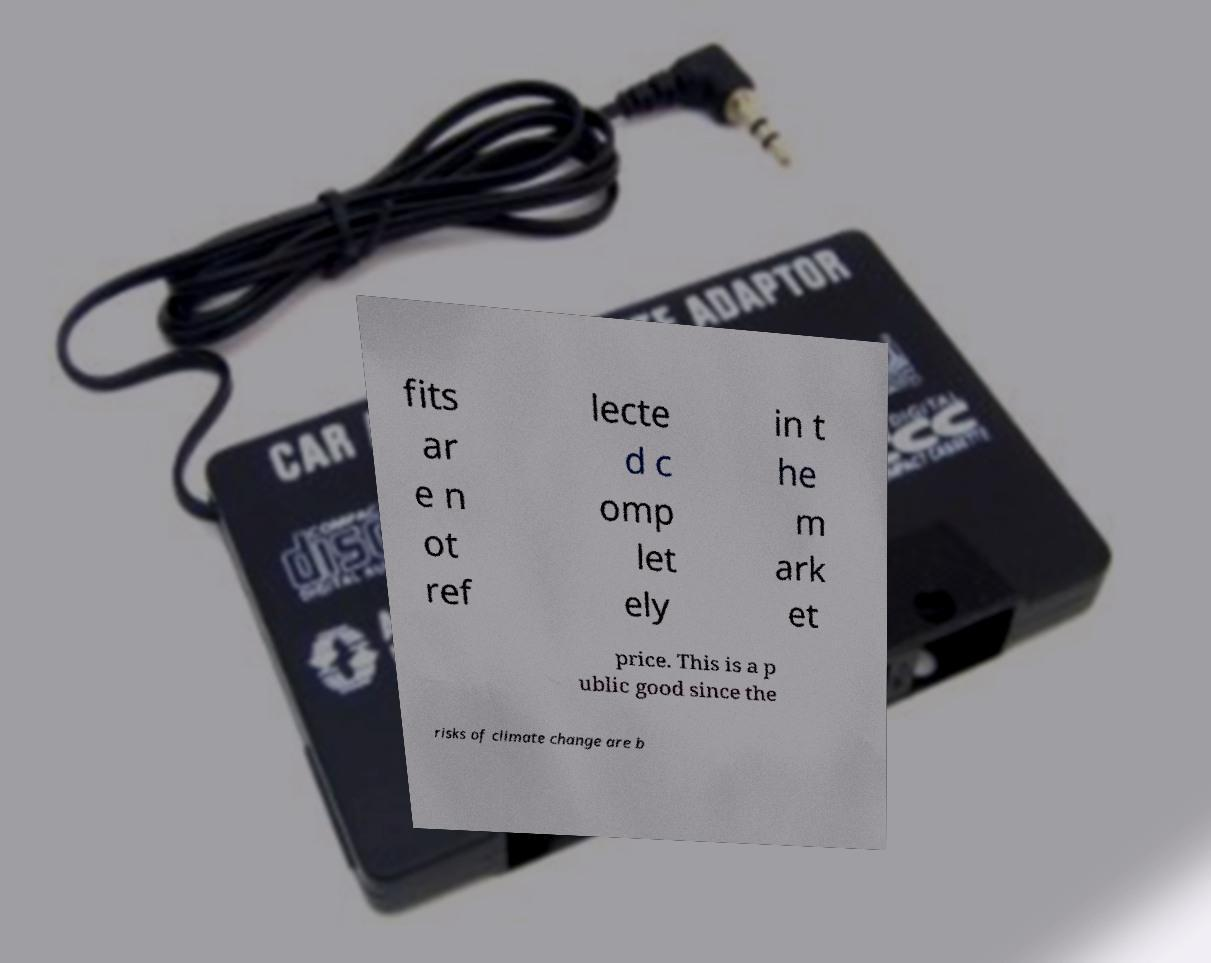What messages or text are displayed in this image? I need them in a readable, typed format. fits ar e n ot ref lecte d c omp let ely in t he m ark et price. This is a p ublic good since the risks of climate change are b 